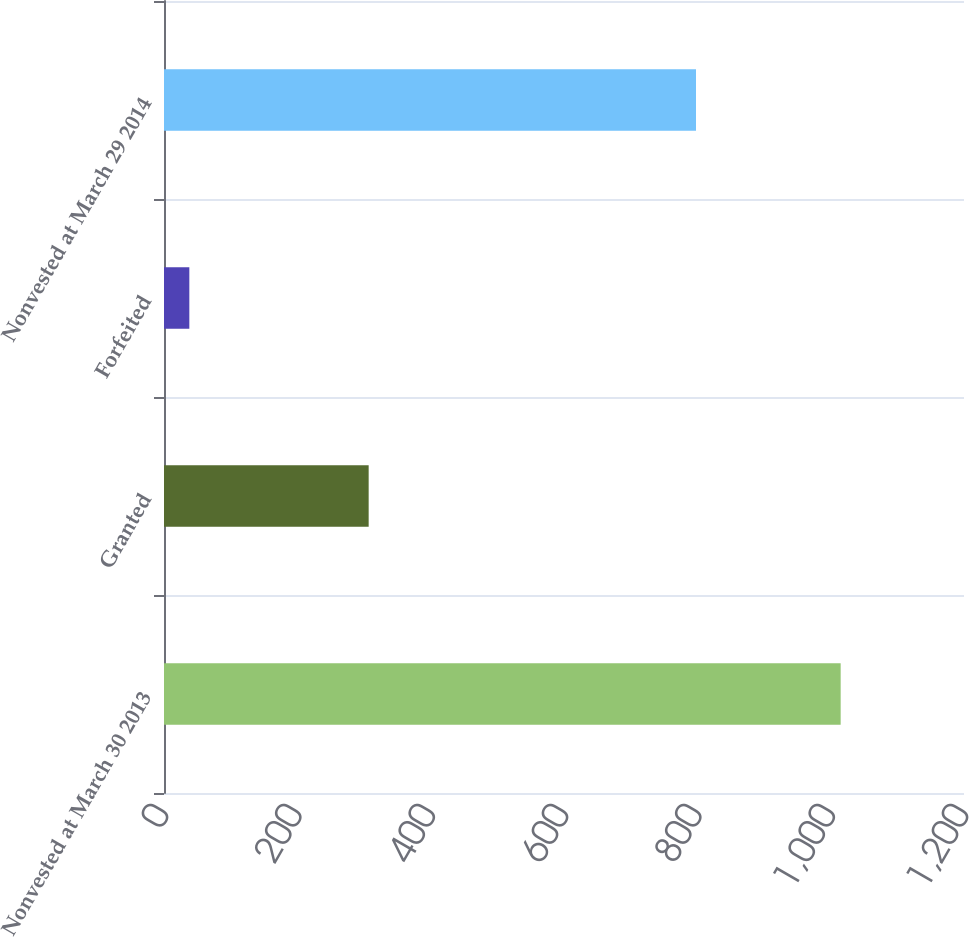<chart> <loc_0><loc_0><loc_500><loc_500><bar_chart><fcel>Nonvested at March 30 2013<fcel>Granted<fcel>Forfeited<fcel>Nonvested at March 29 2014<nl><fcel>1015<fcel>307<fcel>38<fcel>798<nl></chart> 